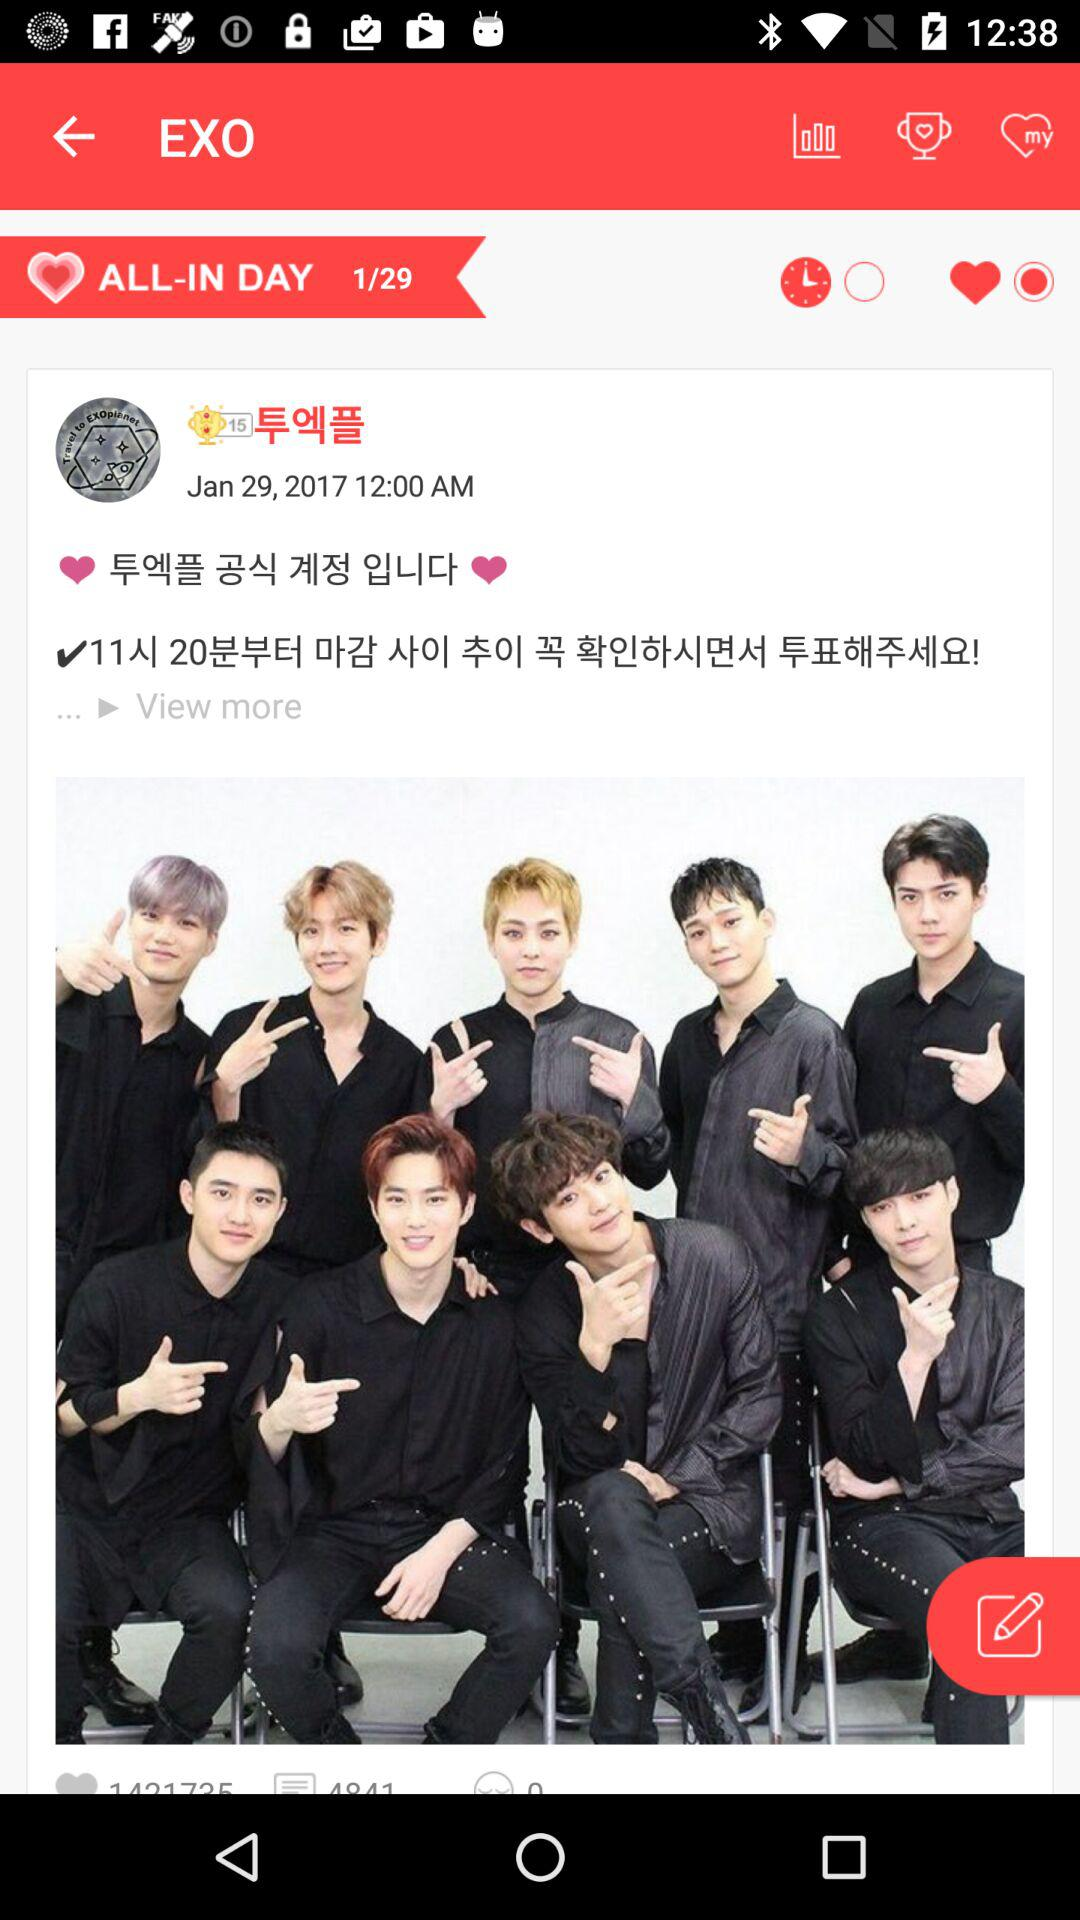What is the application name? The application name is "EXO". 